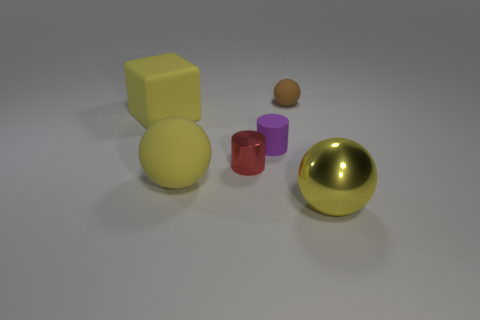Add 3 blocks. How many objects exist? 9 Subtract all cubes. How many objects are left? 5 Add 2 tiny purple matte cylinders. How many tiny purple matte cylinders are left? 3 Add 3 large red metallic cubes. How many large red metallic cubes exist? 3 Subtract 0 gray balls. How many objects are left? 6 Subtract all tiny brown rubber spheres. Subtract all small gray matte things. How many objects are left? 5 